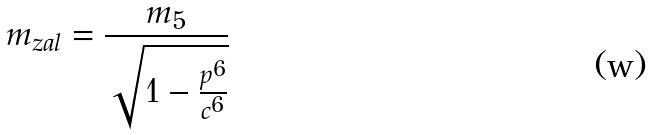<formula> <loc_0><loc_0><loc_500><loc_500>m _ { z a l } = \frac { m _ { 5 } } { \sqrt { 1 - \frac { p ^ { 6 } } { c ^ { 6 } } } }</formula> 